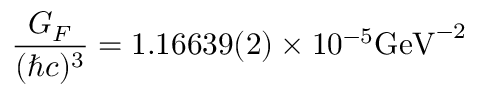<formula> <loc_0><loc_0><loc_500><loc_500>\frac { G _ { F } } { ( \hbar { c } ) ^ { 3 } } = 1 . 1 6 6 3 9 ( 2 ) \times 1 0 ^ { - 5 } G e V ^ { - 2 }</formula> 